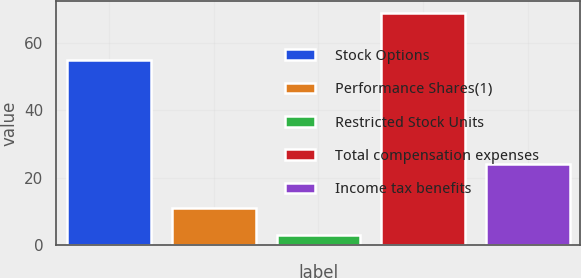<chart> <loc_0><loc_0><loc_500><loc_500><bar_chart><fcel>Stock Options<fcel>Performance Shares(1)<fcel>Restricted Stock Units<fcel>Total compensation expenses<fcel>Income tax benefits<nl><fcel>55<fcel>11<fcel>3<fcel>69<fcel>24<nl></chart> 